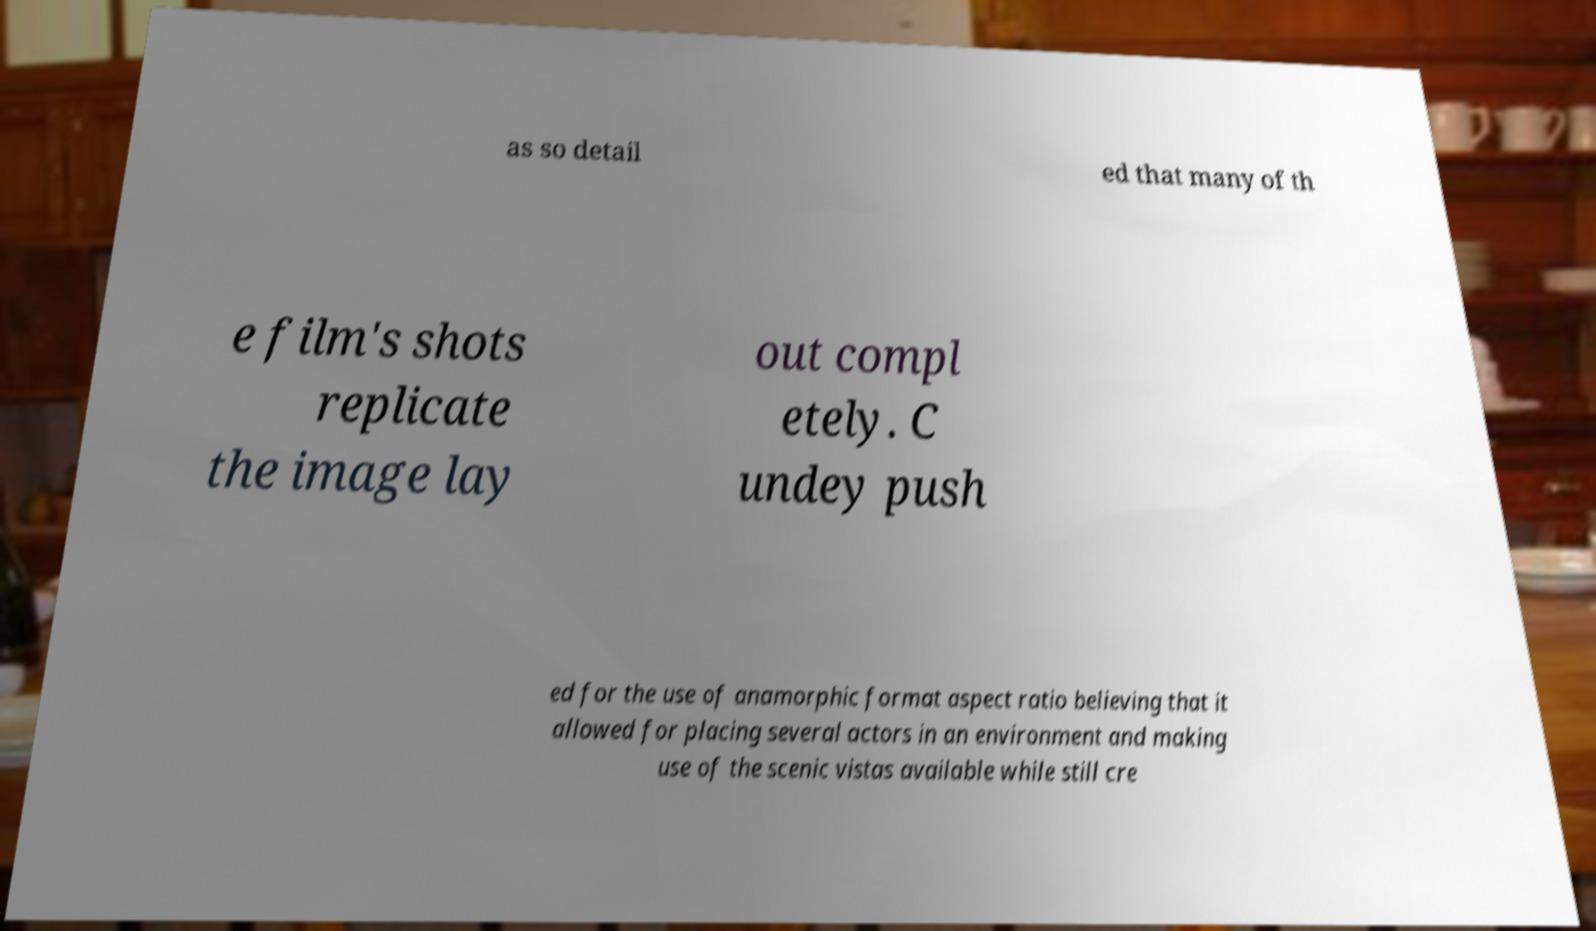What messages or text are displayed in this image? I need them in a readable, typed format. as so detail ed that many of th e film's shots replicate the image lay out compl etely. C undey push ed for the use of anamorphic format aspect ratio believing that it allowed for placing several actors in an environment and making use of the scenic vistas available while still cre 